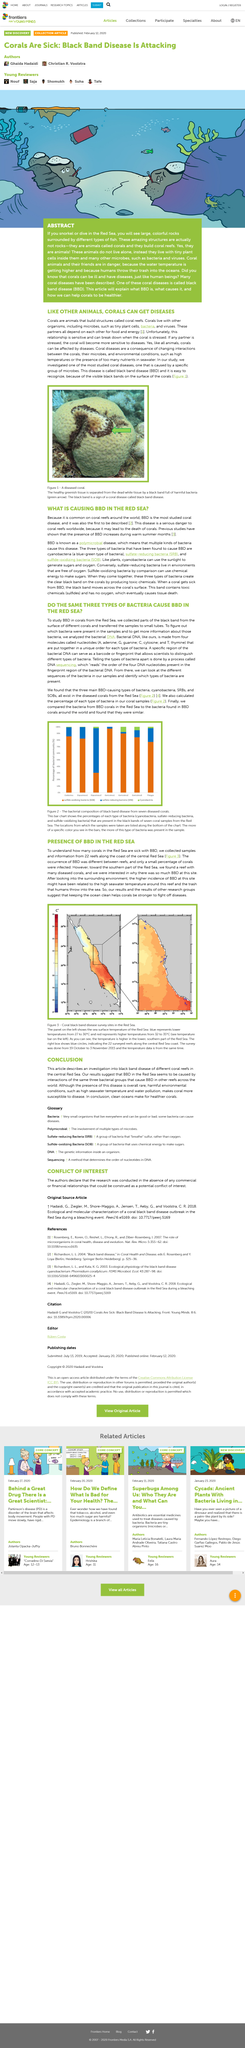Specify some key components in this picture. To promote the health and resilience of coral, it is essential to maintain a clean and well-regulated ocean environment. By taking measures to prevent pollution and control the spread of disease, we can support the natural defenses of these vital ecosystems and enhance their ability to withstand the challenges of a changing climate. BBD stands for Black Bland Disease. Scientists discovered a significant amount of diseased coral with an abundance of BBD in the Red Sea. Cyanobacteria are the causative bacteria for BBD. The relationship between A and B is interdependent, as they rely on each other for sustenance. A provides food and energy for B, while B supplies A with necessary resources. 